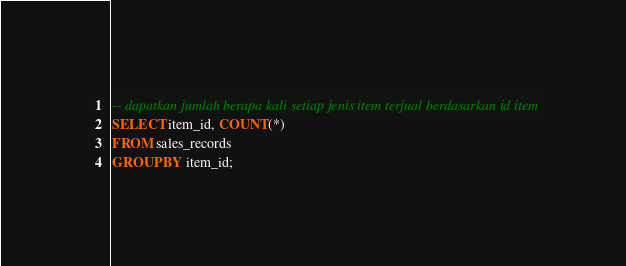<code> <loc_0><loc_0><loc_500><loc_500><_SQL_>-- dapatkan jumlah berapa kali setiap jenis item terjual berdasarkan id item
SELECT item_id, COUNT(*)
FROM sales_records
GROUP BY item_id;</code> 